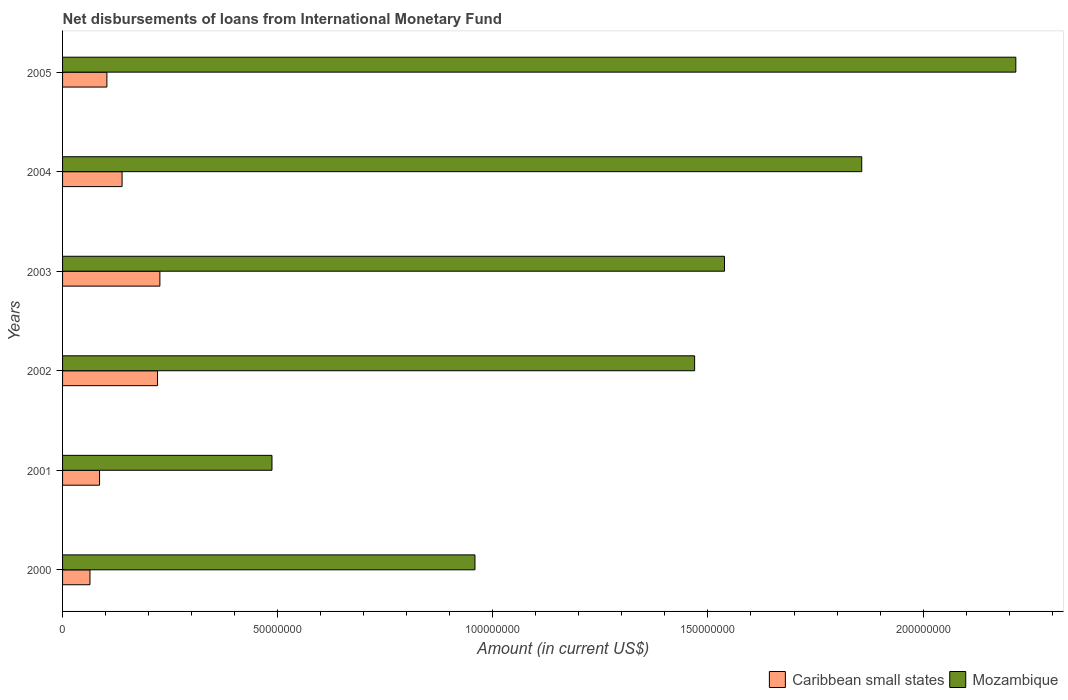How many groups of bars are there?
Keep it short and to the point. 6. Are the number of bars on each tick of the Y-axis equal?
Your answer should be very brief. Yes. What is the amount of loans disbursed in Caribbean small states in 2003?
Offer a very short reply. 2.26e+07. Across all years, what is the maximum amount of loans disbursed in Mozambique?
Offer a terse response. 2.22e+08. Across all years, what is the minimum amount of loans disbursed in Caribbean small states?
Provide a short and direct response. 6.37e+06. What is the total amount of loans disbursed in Mozambique in the graph?
Offer a terse response. 8.53e+08. What is the difference between the amount of loans disbursed in Caribbean small states in 2000 and that in 2004?
Offer a terse response. -7.46e+06. What is the difference between the amount of loans disbursed in Mozambique in 2005 and the amount of loans disbursed in Caribbean small states in 2002?
Your answer should be compact. 1.99e+08. What is the average amount of loans disbursed in Mozambique per year?
Your response must be concise. 1.42e+08. In the year 2005, what is the difference between the amount of loans disbursed in Caribbean small states and amount of loans disbursed in Mozambique?
Provide a short and direct response. -2.11e+08. What is the ratio of the amount of loans disbursed in Mozambique in 2001 to that in 2003?
Offer a terse response. 0.32. Is the amount of loans disbursed in Mozambique in 2001 less than that in 2003?
Offer a terse response. Yes. What is the difference between the highest and the second highest amount of loans disbursed in Caribbean small states?
Your answer should be very brief. 5.50e+05. What is the difference between the highest and the lowest amount of loans disbursed in Mozambique?
Keep it short and to the point. 1.73e+08. What does the 1st bar from the top in 2005 represents?
Provide a short and direct response. Mozambique. What does the 1st bar from the bottom in 2000 represents?
Offer a very short reply. Caribbean small states. How many bars are there?
Provide a short and direct response. 12. Are the values on the major ticks of X-axis written in scientific E-notation?
Your answer should be compact. No. Where does the legend appear in the graph?
Your answer should be very brief. Bottom right. How many legend labels are there?
Make the answer very short. 2. What is the title of the graph?
Keep it short and to the point. Net disbursements of loans from International Monetary Fund. Does "Europe(developing only)" appear as one of the legend labels in the graph?
Your response must be concise. No. What is the label or title of the Y-axis?
Provide a succinct answer. Years. What is the Amount (in current US$) in Caribbean small states in 2000?
Offer a terse response. 6.37e+06. What is the Amount (in current US$) in Mozambique in 2000?
Make the answer very short. 9.59e+07. What is the Amount (in current US$) of Caribbean small states in 2001?
Offer a very short reply. 8.60e+06. What is the Amount (in current US$) of Mozambique in 2001?
Offer a terse response. 4.87e+07. What is the Amount (in current US$) of Caribbean small states in 2002?
Your response must be concise. 2.21e+07. What is the Amount (in current US$) in Mozambique in 2002?
Offer a very short reply. 1.47e+08. What is the Amount (in current US$) in Caribbean small states in 2003?
Ensure brevity in your answer.  2.26e+07. What is the Amount (in current US$) of Mozambique in 2003?
Make the answer very short. 1.54e+08. What is the Amount (in current US$) of Caribbean small states in 2004?
Your response must be concise. 1.38e+07. What is the Amount (in current US$) of Mozambique in 2004?
Provide a succinct answer. 1.86e+08. What is the Amount (in current US$) in Caribbean small states in 2005?
Give a very brief answer. 1.03e+07. What is the Amount (in current US$) in Mozambique in 2005?
Your answer should be compact. 2.22e+08. Across all years, what is the maximum Amount (in current US$) in Caribbean small states?
Make the answer very short. 2.26e+07. Across all years, what is the maximum Amount (in current US$) in Mozambique?
Offer a very short reply. 2.22e+08. Across all years, what is the minimum Amount (in current US$) of Caribbean small states?
Keep it short and to the point. 6.37e+06. Across all years, what is the minimum Amount (in current US$) of Mozambique?
Keep it short and to the point. 4.87e+07. What is the total Amount (in current US$) in Caribbean small states in the graph?
Keep it short and to the point. 8.38e+07. What is the total Amount (in current US$) in Mozambique in the graph?
Your answer should be very brief. 8.53e+08. What is the difference between the Amount (in current US$) of Caribbean small states in 2000 and that in 2001?
Make the answer very short. -2.23e+06. What is the difference between the Amount (in current US$) of Mozambique in 2000 and that in 2001?
Offer a terse response. 4.72e+07. What is the difference between the Amount (in current US$) of Caribbean small states in 2000 and that in 2002?
Ensure brevity in your answer.  -1.57e+07. What is the difference between the Amount (in current US$) of Mozambique in 2000 and that in 2002?
Your answer should be compact. -5.11e+07. What is the difference between the Amount (in current US$) in Caribbean small states in 2000 and that in 2003?
Make the answer very short. -1.63e+07. What is the difference between the Amount (in current US$) in Mozambique in 2000 and that in 2003?
Keep it short and to the point. -5.80e+07. What is the difference between the Amount (in current US$) in Caribbean small states in 2000 and that in 2004?
Ensure brevity in your answer.  -7.46e+06. What is the difference between the Amount (in current US$) in Mozambique in 2000 and that in 2004?
Make the answer very short. -8.99e+07. What is the difference between the Amount (in current US$) in Caribbean small states in 2000 and that in 2005?
Your answer should be very brief. -3.93e+06. What is the difference between the Amount (in current US$) of Mozambique in 2000 and that in 2005?
Make the answer very short. -1.26e+08. What is the difference between the Amount (in current US$) of Caribbean small states in 2001 and that in 2002?
Ensure brevity in your answer.  -1.35e+07. What is the difference between the Amount (in current US$) in Mozambique in 2001 and that in 2002?
Ensure brevity in your answer.  -9.82e+07. What is the difference between the Amount (in current US$) in Caribbean small states in 2001 and that in 2003?
Ensure brevity in your answer.  -1.40e+07. What is the difference between the Amount (in current US$) in Mozambique in 2001 and that in 2003?
Offer a very short reply. -1.05e+08. What is the difference between the Amount (in current US$) in Caribbean small states in 2001 and that in 2004?
Give a very brief answer. -5.24e+06. What is the difference between the Amount (in current US$) of Mozambique in 2001 and that in 2004?
Give a very brief answer. -1.37e+08. What is the difference between the Amount (in current US$) in Caribbean small states in 2001 and that in 2005?
Provide a succinct answer. -1.70e+06. What is the difference between the Amount (in current US$) of Mozambique in 2001 and that in 2005?
Ensure brevity in your answer.  -1.73e+08. What is the difference between the Amount (in current US$) of Caribbean small states in 2002 and that in 2003?
Make the answer very short. -5.50e+05. What is the difference between the Amount (in current US$) of Mozambique in 2002 and that in 2003?
Offer a terse response. -6.94e+06. What is the difference between the Amount (in current US$) of Caribbean small states in 2002 and that in 2004?
Give a very brief answer. 8.24e+06. What is the difference between the Amount (in current US$) in Mozambique in 2002 and that in 2004?
Make the answer very short. -3.88e+07. What is the difference between the Amount (in current US$) of Caribbean small states in 2002 and that in 2005?
Your answer should be very brief. 1.18e+07. What is the difference between the Amount (in current US$) of Mozambique in 2002 and that in 2005?
Provide a succinct answer. -7.47e+07. What is the difference between the Amount (in current US$) of Caribbean small states in 2003 and that in 2004?
Ensure brevity in your answer.  8.79e+06. What is the difference between the Amount (in current US$) in Mozambique in 2003 and that in 2004?
Keep it short and to the point. -3.19e+07. What is the difference between the Amount (in current US$) of Caribbean small states in 2003 and that in 2005?
Offer a terse response. 1.23e+07. What is the difference between the Amount (in current US$) of Mozambique in 2003 and that in 2005?
Your answer should be very brief. -6.77e+07. What is the difference between the Amount (in current US$) of Caribbean small states in 2004 and that in 2005?
Offer a very short reply. 3.53e+06. What is the difference between the Amount (in current US$) in Mozambique in 2004 and that in 2005?
Provide a short and direct response. -3.58e+07. What is the difference between the Amount (in current US$) in Caribbean small states in 2000 and the Amount (in current US$) in Mozambique in 2001?
Offer a terse response. -4.23e+07. What is the difference between the Amount (in current US$) in Caribbean small states in 2000 and the Amount (in current US$) in Mozambique in 2002?
Keep it short and to the point. -1.41e+08. What is the difference between the Amount (in current US$) of Caribbean small states in 2000 and the Amount (in current US$) of Mozambique in 2003?
Offer a terse response. -1.47e+08. What is the difference between the Amount (in current US$) in Caribbean small states in 2000 and the Amount (in current US$) in Mozambique in 2004?
Offer a very short reply. -1.79e+08. What is the difference between the Amount (in current US$) in Caribbean small states in 2000 and the Amount (in current US$) in Mozambique in 2005?
Offer a terse response. -2.15e+08. What is the difference between the Amount (in current US$) of Caribbean small states in 2001 and the Amount (in current US$) of Mozambique in 2002?
Keep it short and to the point. -1.38e+08. What is the difference between the Amount (in current US$) in Caribbean small states in 2001 and the Amount (in current US$) in Mozambique in 2003?
Offer a very short reply. -1.45e+08. What is the difference between the Amount (in current US$) of Caribbean small states in 2001 and the Amount (in current US$) of Mozambique in 2004?
Keep it short and to the point. -1.77e+08. What is the difference between the Amount (in current US$) of Caribbean small states in 2001 and the Amount (in current US$) of Mozambique in 2005?
Your answer should be compact. -2.13e+08. What is the difference between the Amount (in current US$) of Caribbean small states in 2002 and the Amount (in current US$) of Mozambique in 2003?
Your response must be concise. -1.32e+08. What is the difference between the Amount (in current US$) of Caribbean small states in 2002 and the Amount (in current US$) of Mozambique in 2004?
Offer a terse response. -1.64e+08. What is the difference between the Amount (in current US$) in Caribbean small states in 2002 and the Amount (in current US$) in Mozambique in 2005?
Ensure brevity in your answer.  -1.99e+08. What is the difference between the Amount (in current US$) of Caribbean small states in 2003 and the Amount (in current US$) of Mozambique in 2004?
Offer a terse response. -1.63e+08. What is the difference between the Amount (in current US$) of Caribbean small states in 2003 and the Amount (in current US$) of Mozambique in 2005?
Provide a succinct answer. -1.99e+08. What is the difference between the Amount (in current US$) of Caribbean small states in 2004 and the Amount (in current US$) of Mozambique in 2005?
Make the answer very short. -2.08e+08. What is the average Amount (in current US$) in Caribbean small states per year?
Your answer should be compact. 1.40e+07. What is the average Amount (in current US$) in Mozambique per year?
Give a very brief answer. 1.42e+08. In the year 2000, what is the difference between the Amount (in current US$) in Caribbean small states and Amount (in current US$) in Mozambique?
Make the answer very short. -8.95e+07. In the year 2001, what is the difference between the Amount (in current US$) of Caribbean small states and Amount (in current US$) of Mozambique?
Ensure brevity in your answer.  -4.01e+07. In the year 2002, what is the difference between the Amount (in current US$) of Caribbean small states and Amount (in current US$) of Mozambique?
Provide a succinct answer. -1.25e+08. In the year 2003, what is the difference between the Amount (in current US$) in Caribbean small states and Amount (in current US$) in Mozambique?
Offer a very short reply. -1.31e+08. In the year 2004, what is the difference between the Amount (in current US$) of Caribbean small states and Amount (in current US$) of Mozambique?
Your response must be concise. -1.72e+08. In the year 2005, what is the difference between the Amount (in current US$) of Caribbean small states and Amount (in current US$) of Mozambique?
Keep it short and to the point. -2.11e+08. What is the ratio of the Amount (in current US$) of Caribbean small states in 2000 to that in 2001?
Provide a short and direct response. 0.74. What is the ratio of the Amount (in current US$) of Mozambique in 2000 to that in 2001?
Make the answer very short. 1.97. What is the ratio of the Amount (in current US$) of Caribbean small states in 2000 to that in 2002?
Provide a succinct answer. 0.29. What is the ratio of the Amount (in current US$) of Mozambique in 2000 to that in 2002?
Offer a very short reply. 0.65. What is the ratio of the Amount (in current US$) in Caribbean small states in 2000 to that in 2003?
Offer a terse response. 0.28. What is the ratio of the Amount (in current US$) of Mozambique in 2000 to that in 2003?
Ensure brevity in your answer.  0.62. What is the ratio of the Amount (in current US$) of Caribbean small states in 2000 to that in 2004?
Provide a short and direct response. 0.46. What is the ratio of the Amount (in current US$) of Mozambique in 2000 to that in 2004?
Your answer should be compact. 0.52. What is the ratio of the Amount (in current US$) in Caribbean small states in 2000 to that in 2005?
Your response must be concise. 0.62. What is the ratio of the Amount (in current US$) in Mozambique in 2000 to that in 2005?
Offer a very short reply. 0.43. What is the ratio of the Amount (in current US$) in Caribbean small states in 2001 to that in 2002?
Your answer should be very brief. 0.39. What is the ratio of the Amount (in current US$) in Mozambique in 2001 to that in 2002?
Offer a very short reply. 0.33. What is the ratio of the Amount (in current US$) in Caribbean small states in 2001 to that in 2003?
Make the answer very short. 0.38. What is the ratio of the Amount (in current US$) in Mozambique in 2001 to that in 2003?
Provide a succinct answer. 0.32. What is the ratio of the Amount (in current US$) in Caribbean small states in 2001 to that in 2004?
Ensure brevity in your answer.  0.62. What is the ratio of the Amount (in current US$) in Mozambique in 2001 to that in 2004?
Make the answer very short. 0.26. What is the ratio of the Amount (in current US$) of Caribbean small states in 2001 to that in 2005?
Ensure brevity in your answer.  0.83. What is the ratio of the Amount (in current US$) in Mozambique in 2001 to that in 2005?
Offer a very short reply. 0.22. What is the ratio of the Amount (in current US$) in Caribbean small states in 2002 to that in 2003?
Your response must be concise. 0.98. What is the ratio of the Amount (in current US$) in Mozambique in 2002 to that in 2003?
Give a very brief answer. 0.95. What is the ratio of the Amount (in current US$) in Caribbean small states in 2002 to that in 2004?
Offer a terse response. 1.6. What is the ratio of the Amount (in current US$) in Mozambique in 2002 to that in 2004?
Offer a very short reply. 0.79. What is the ratio of the Amount (in current US$) in Caribbean small states in 2002 to that in 2005?
Provide a succinct answer. 2.14. What is the ratio of the Amount (in current US$) in Mozambique in 2002 to that in 2005?
Give a very brief answer. 0.66. What is the ratio of the Amount (in current US$) of Caribbean small states in 2003 to that in 2004?
Keep it short and to the point. 1.64. What is the ratio of the Amount (in current US$) of Mozambique in 2003 to that in 2004?
Offer a terse response. 0.83. What is the ratio of the Amount (in current US$) of Caribbean small states in 2003 to that in 2005?
Give a very brief answer. 2.2. What is the ratio of the Amount (in current US$) in Mozambique in 2003 to that in 2005?
Offer a very short reply. 0.69. What is the ratio of the Amount (in current US$) of Caribbean small states in 2004 to that in 2005?
Your answer should be compact. 1.34. What is the ratio of the Amount (in current US$) of Mozambique in 2004 to that in 2005?
Make the answer very short. 0.84. What is the difference between the highest and the second highest Amount (in current US$) of Mozambique?
Keep it short and to the point. 3.58e+07. What is the difference between the highest and the lowest Amount (in current US$) in Caribbean small states?
Offer a terse response. 1.63e+07. What is the difference between the highest and the lowest Amount (in current US$) in Mozambique?
Provide a short and direct response. 1.73e+08. 